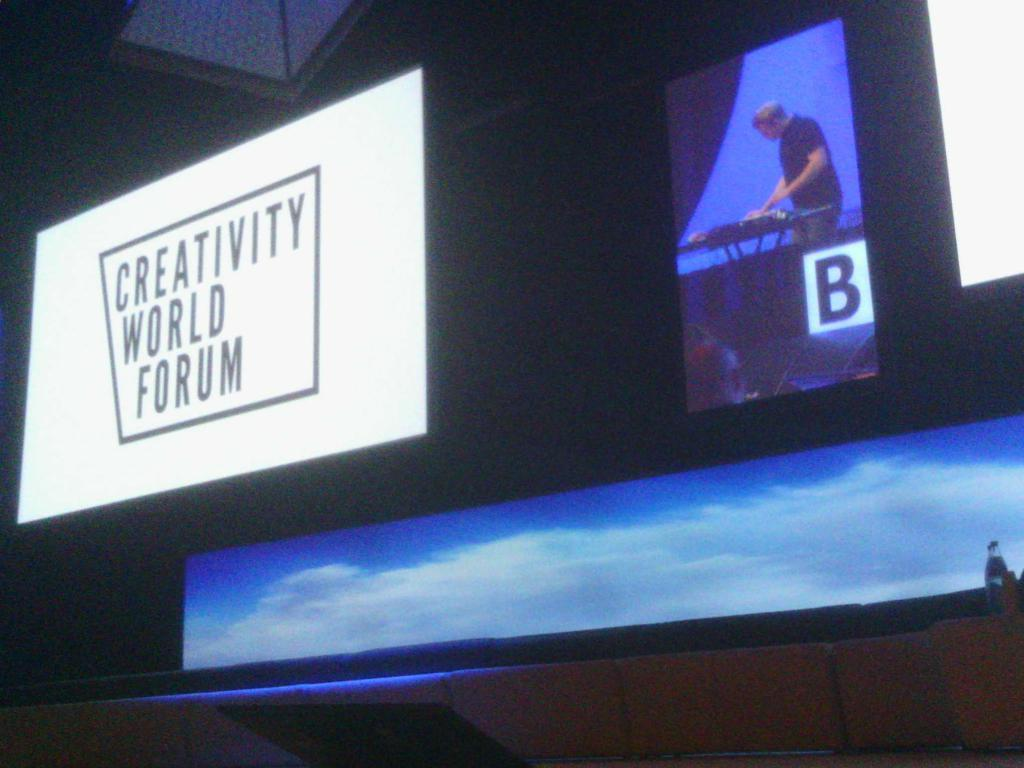<image>
Offer a succinct explanation of the picture presented. Someone plays the keyboard at the Creativity World Forum. 